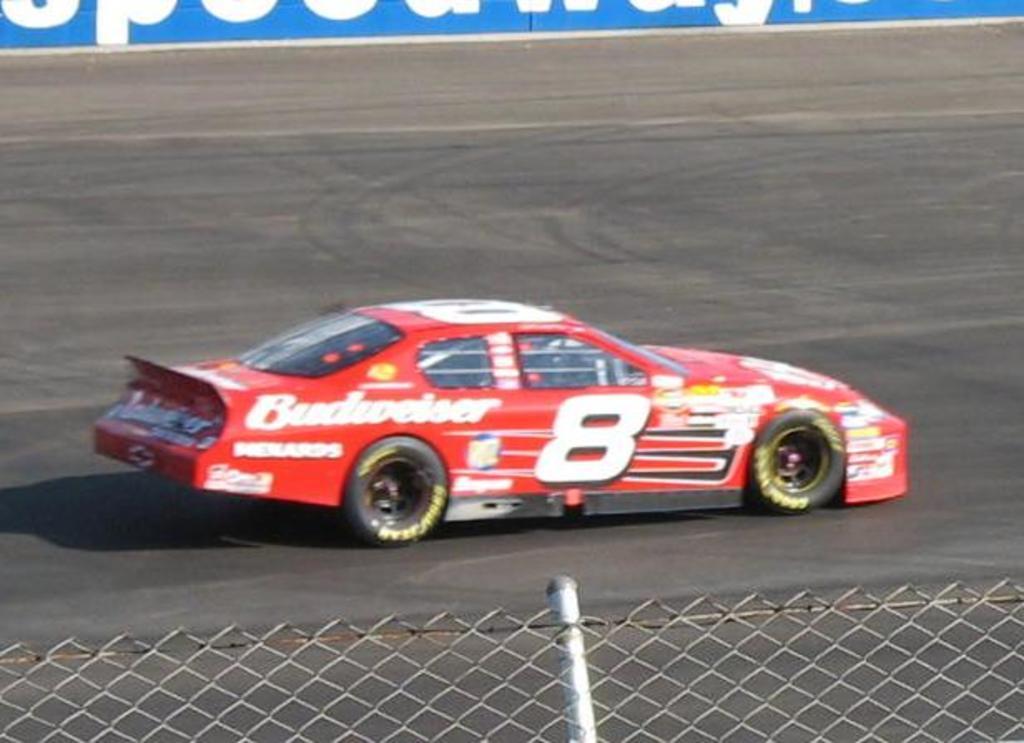How would you summarize this image in a sentence or two? This image consists of a car. It is in red color. There is a fence at the bottom. 